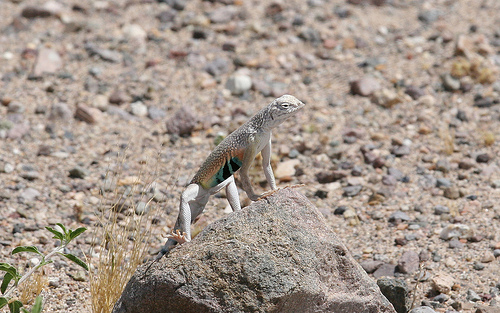<image>
Can you confirm if the lizard is on the ground? No. The lizard is not positioned on the ground. They may be near each other, but the lizard is not supported by or resting on top of the ground. 